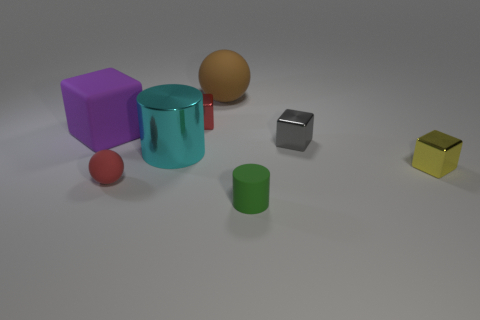Is there a shiny thing of the same color as the metal cylinder?
Make the answer very short. No. What material is the cyan cylinder?
Offer a terse response. Metal. How many objects are either matte cylinders or large yellow things?
Your answer should be compact. 1. What is the size of the ball that is on the right side of the tiny red rubber sphere?
Provide a succinct answer. Large. What number of other things are there of the same material as the yellow object
Offer a terse response. 3. There is a ball left of the tiny red cube; is there a metallic cylinder that is left of it?
Provide a short and direct response. No. Is there anything else that has the same shape as the big cyan metallic object?
Offer a very short reply. Yes. There is a large object that is the same shape as the tiny red matte object; what is its color?
Your answer should be compact. Brown. How big is the green object?
Make the answer very short. Small. Are there fewer tiny gray metallic things left of the green cylinder than tiny red rubber blocks?
Provide a succinct answer. No. 